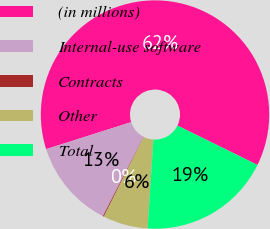Convert chart. <chart><loc_0><loc_0><loc_500><loc_500><pie_chart><fcel>(in millions)<fcel>Internal-use software<fcel>Contracts<fcel>Other<fcel>Total<nl><fcel>62.17%<fcel>12.56%<fcel>0.15%<fcel>6.36%<fcel>18.76%<nl></chart> 